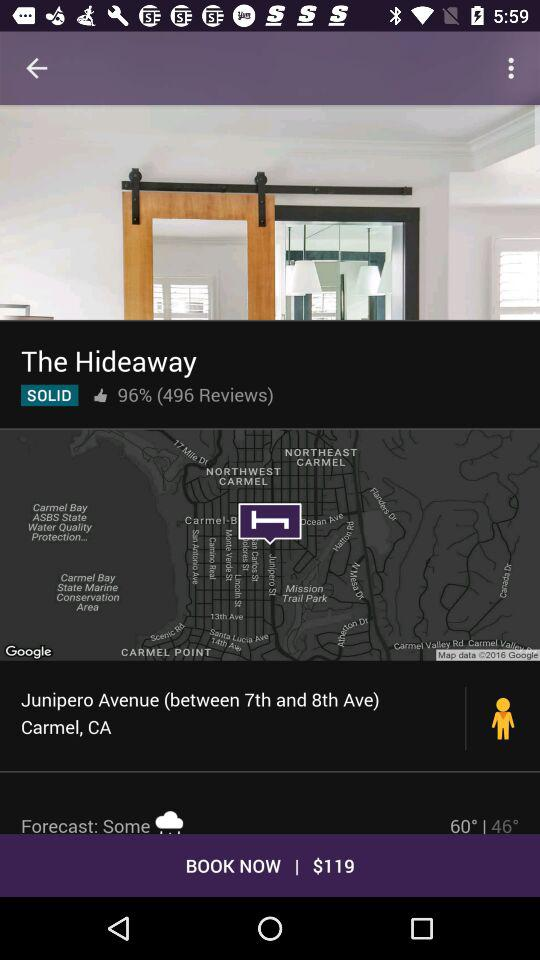In which currency is the booking price? The booking price is in dollars. 